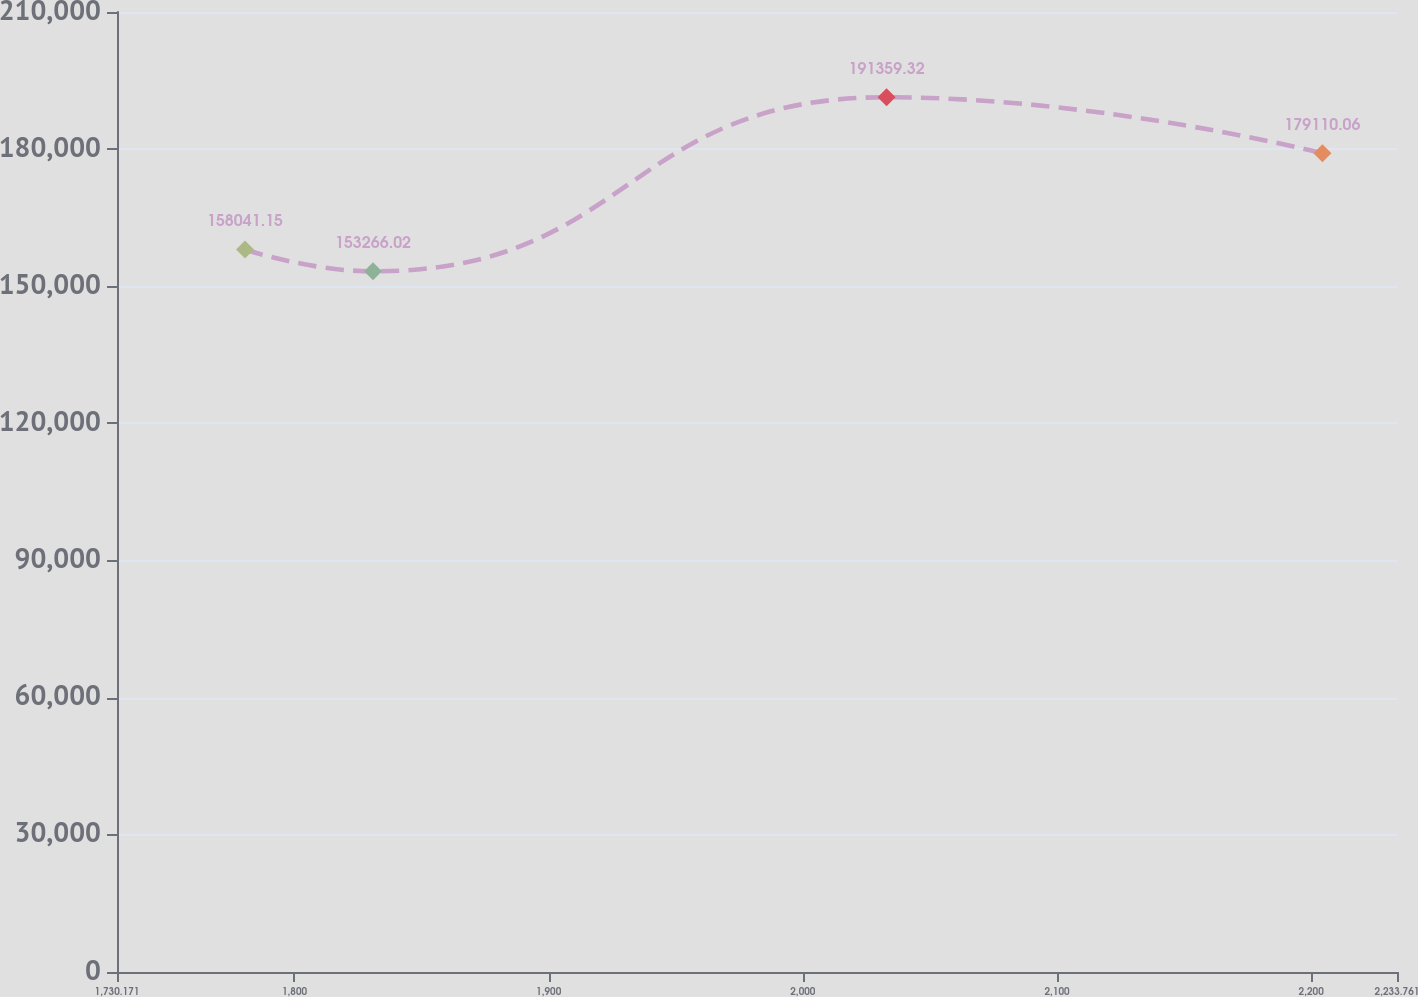Convert chart to OTSL. <chart><loc_0><loc_0><loc_500><loc_500><line_chart><ecel><fcel>Unnamed: 1<nl><fcel>1780.53<fcel>158041<nl><fcel>1830.89<fcel>153266<nl><fcel>2032.95<fcel>191359<nl><fcel>2204.43<fcel>179110<nl><fcel>2284.12<fcel>143608<nl></chart> 